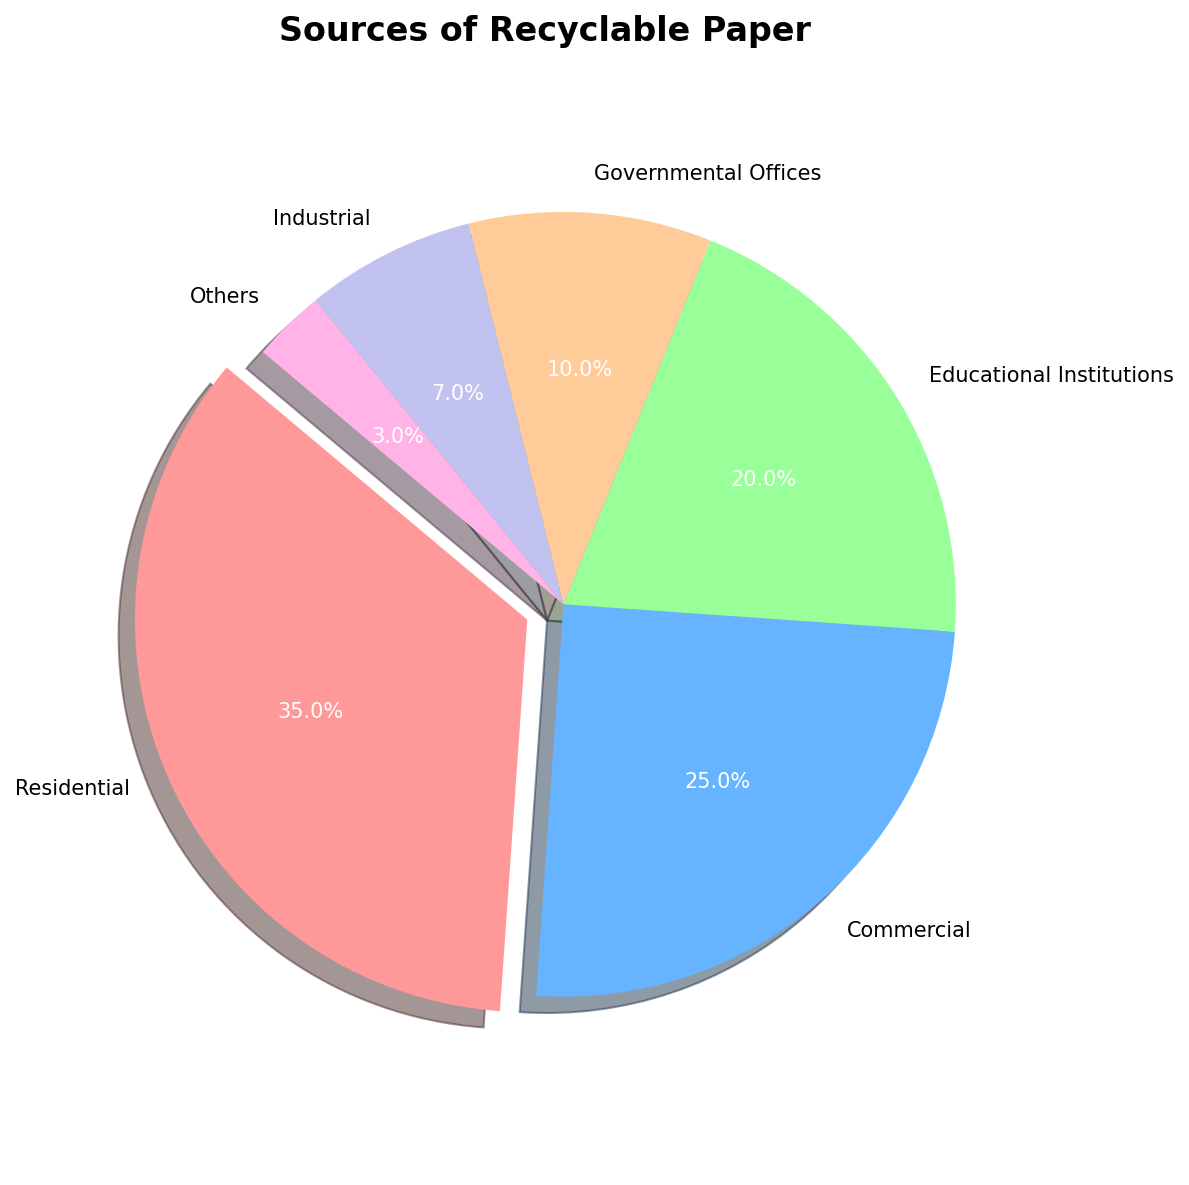What percentage of recyclable paper comes from educational institutions? Educational Institutions account for 20% of the recyclable paper, as indicated by the pie chart slice labeled "Educational Institutions" with a percentage of 20% marked on it.
Answer: 20% Which source contributes the least to recyclable paper? According to the pie chart, the "Others" category contributes the least, with a percentage of 3%.
Answer: Others How much more recyclable paper comes from residential sources compared to governmental offices? The pie chart shows 35% for residential and 10% for governmental offices. The difference is calculated as 35% - 10% = 25%.
Answer: 25% Are the contributions of industrial and governmental offices combined greater than the contribution from educational institutions? Industrial and governmental offices together contribute 7% + 10% = 17%. Educational institutions contribute 20%. Therefore, 17% is less than 20%.
Answer: No What fraction of the recyclable paper comes from sources other than residential, rounded to the nearest hundredth? Residential contributes 35%, so the rest is 100% - 35% = 65%. As a fraction, this is 65/100 = 0.65 when rounded to the nearest hundredth.
Answer: 0.65 Is the size of the slice representing commercial sources larger than the slice for industrial sources? Yes, commercial sources contribute 25%, while industrial sources contribute 7%, making the commercial slice larger.
Answer: Yes Which two sources combined contribute exactly half of the recyclable paper? The pie chart shows that Residential (35%) and Commercial (25%) combined contribute 35% + 25% = 60%, which is not correct. However, combining Educational Institutions (20%) and Commercial (25%), we get 20% + 25% = 45%. The correct answer would be between Residential (35%) and Industrial (7%) which equals 42%, or Residential (35%) and Commercial (25%) equals 60%, neither of which equals 50%. So no two categories exactly sum to 50%.
Answer: None What is the combined contribution of commercial and educational institutions compared to residential and governmental offices? Commercial and educational institutions contribute 25% + 20% = 45%. Residential and governmental offices contribute 35% + 10% = 45%. Both sums are equal, so the combined contributions are the same.
Answer: Equal If you combine commercial, governmental offices, and others, how does their total percentage compare to residential alone? Combining Commercial (25%), Governmental Offices (10%), and Others (3%) gives 25% + 10% + 3% = 38%. Residential alone is 35%. Therefore, 38% is greater than 35%.
Answer: Greater 